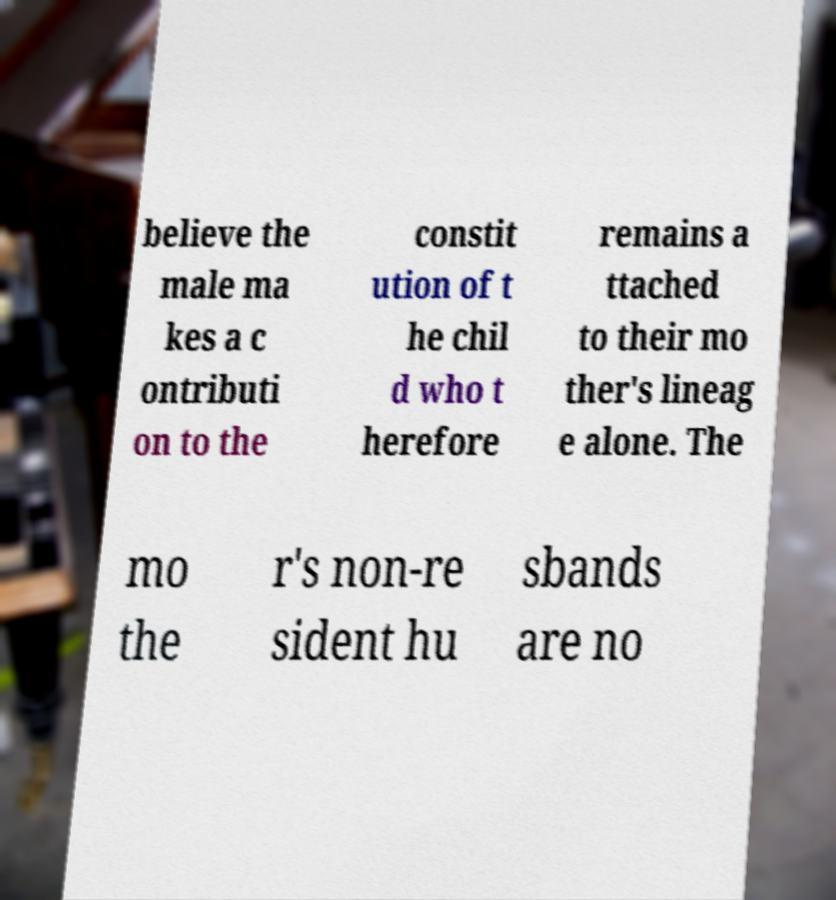There's text embedded in this image that I need extracted. Can you transcribe it verbatim? believe the male ma kes a c ontributi on to the constit ution of t he chil d who t herefore remains a ttached to their mo ther's lineag e alone. The mo the r's non-re sident hu sbands are no 